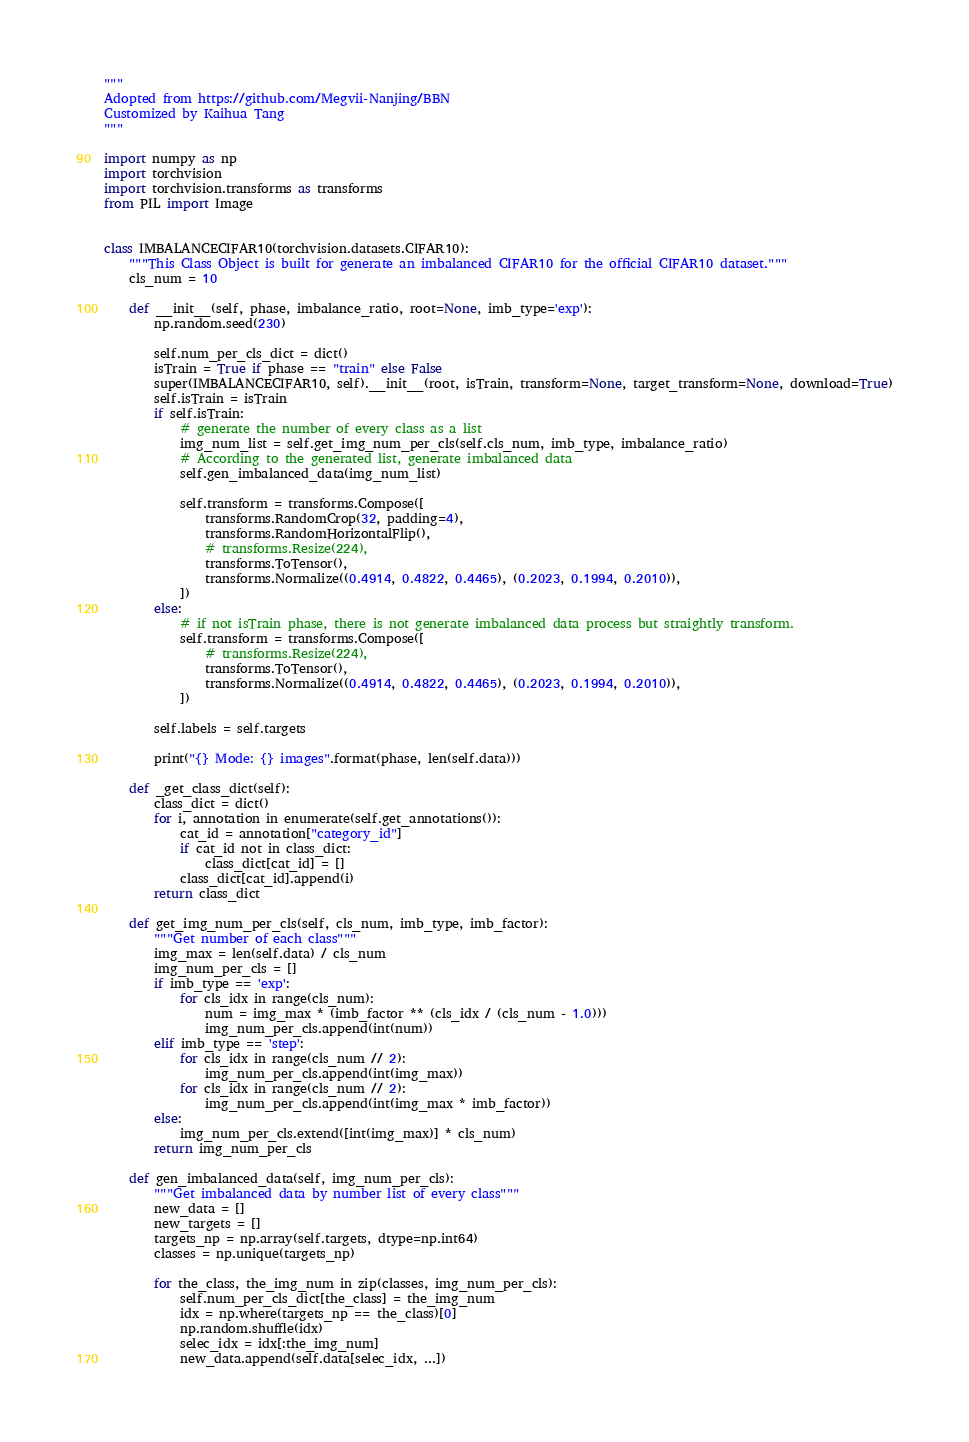<code> <loc_0><loc_0><loc_500><loc_500><_Python_>"""
Adopted from https://github.com/Megvii-Nanjing/BBN
Customized by Kaihua Tang
"""

import numpy as np
import torchvision
import torchvision.transforms as transforms
from PIL import Image


class IMBALANCECIFAR10(torchvision.datasets.CIFAR10):
    """This Class Object is built for generate an imbalanced CIFAR10 for the official CIFAR10 dataset."""
    cls_num = 10

    def __init__(self, phase, imbalance_ratio, root=None, imb_type='exp'):
        np.random.seed(230)

        self.num_per_cls_dict = dict()
        isTrain = True if phase == "train" else False
        super(IMBALANCECIFAR10, self).__init__(root, isTrain, transform=None, target_transform=None, download=True)
        self.isTrain = isTrain
        if self.isTrain:
            # generate the number of every class as a list
            img_num_list = self.get_img_num_per_cls(self.cls_num, imb_type, imbalance_ratio)
            # According to the generated list, generate imbalanced data
            self.gen_imbalanced_data(img_num_list)

            self.transform = transforms.Compose([
                transforms.RandomCrop(32, padding=4),
                transforms.RandomHorizontalFlip(),
                # transforms.Resize(224),
                transforms.ToTensor(),
                transforms.Normalize((0.4914, 0.4822, 0.4465), (0.2023, 0.1994, 0.2010)),
            ])
        else:
            # if not isTrain phase, there is not generate imbalanced data process but straightly transform.
            self.transform = transforms.Compose([
                # transforms.Resize(224),
                transforms.ToTensor(),
                transforms.Normalize((0.4914, 0.4822, 0.4465), (0.2023, 0.1994, 0.2010)),
            ])

        self.labels = self.targets

        print("{} Mode: {} images".format(phase, len(self.data)))

    def _get_class_dict(self):
        class_dict = dict()
        for i, annotation in enumerate(self.get_annotations()):
            cat_id = annotation["category_id"]
            if cat_id not in class_dict:
                class_dict[cat_id] = []
            class_dict[cat_id].append(i)
        return class_dict

    def get_img_num_per_cls(self, cls_num, imb_type, imb_factor):
        """Get number of each class"""
        img_max = len(self.data) / cls_num
        img_num_per_cls = []
        if imb_type == 'exp':
            for cls_idx in range(cls_num):
                num = img_max * (imb_factor ** (cls_idx / (cls_num - 1.0)))
                img_num_per_cls.append(int(num))
        elif imb_type == 'step':
            for cls_idx in range(cls_num // 2):
                img_num_per_cls.append(int(img_max))
            for cls_idx in range(cls_num // 2):
                img_num_per_cls.append(int(img_max * imb_factor))
        else:
            img_num_per_cls.extend([int(img_max)] * cls_num)
        return img_num_per_cls

    def gen_imbalanced_data(self, img_num_per_cls):
        """Get imbalanced data by number list of every class"""
        new_data = []
        new_targets = []
        targets_np = np.array(self.targets, dtype=np.int64)
        classes = np.unique(targets_np)

        for the_class, the_img_num in zip(classes, img_num_per_cls):
            self.num_per_cls_dict[the_class] = the_img_num
            idx = np.where(targets_np == the_class)[0]
            np.random.shuffle(idx)
            selec_idx = idx[:the_img_num]
            new_data.append(self.data[selec_idx, ...])</code> 